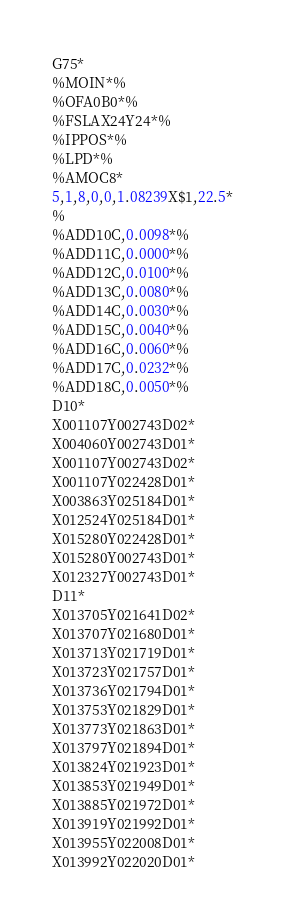Convert code to text. <code><loc_0><loc_0><loc_500><loc_500><_SQL_>G75*
%MOIN*%
%OFA0B0*%
%FSLAX24Y24*%
%IPPOS*%
%LPD*%
%AMOC8*
5,1,8,0,0,1.08239X$1,22.5*
%
%ADD10C,0.0098*%
%ADD11C,0.0000*%
%ADD12C,0.0100*%
%ADD13C,0.0080*%
%ADD14C,0.0030*%
%ADD15C,0.0040*%
%ADD16C,0.0060*%
%ADD17C,0.0232*%
%ADD18C,0.0050*%
D10*
X001107Y002743D02*
X004060Y002743D01*
X001107Y002743D02*
X001107Y022428D01*
X003863Y025184D01*
X012524Y025184D01*
X015280Y022428D01*
X015280Y002743D01*
X012327Y002743D01*
D11*
X013705Y021641D02*
X013707Y021680D01*
X013713Y021719D01*
X013723Y021757D01*
X013736Y021794D01*
X013753Y021829D01*
X013773Y021863D01*
X013797Y021894D01*
X013824Y021923D01*
X013853Y021949D01*
X013885Y021972D01*
X013919Y021992D01*
X013955Y022008D01*
X013992Y022020D01*</code> 